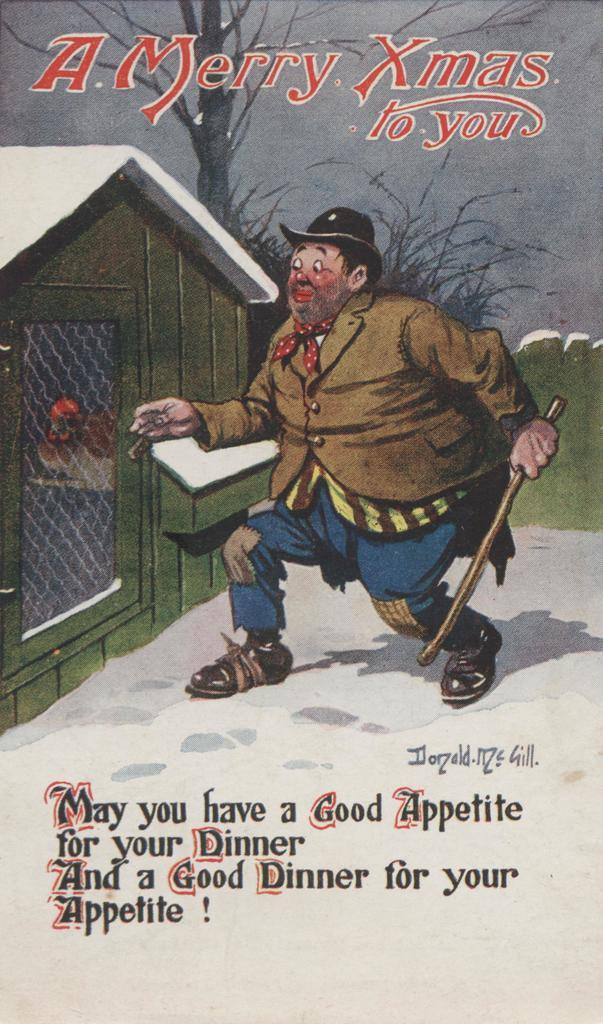What type of poster is in the image? There is a cartoon poster in the image. What is depicted on the cartoon poster? The poster contains a person. Are there any words on the poster? Yes, there is text on the poster. How does the person on the poster connect to the internet? The person on the poster is not a real person and cannot connect to the internet. 